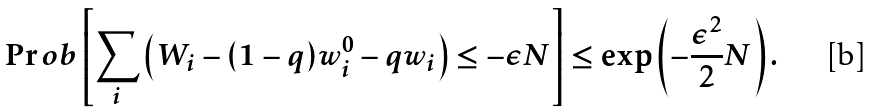Convert formula to latex. <formula><loc_0><loc_0><loc_500><loc_500>\Pr o b \left [ \sum _ { i } \left ( W _ { i } - ( 1 - q ) w ^ { 0 } _ { i } - q w _ { i } \right ) \leq - \epsilon N \right ] \leq \exp \left ( - \frac { \epsilon ^ { 2 } } { 2 } N \right ) .</formula> 